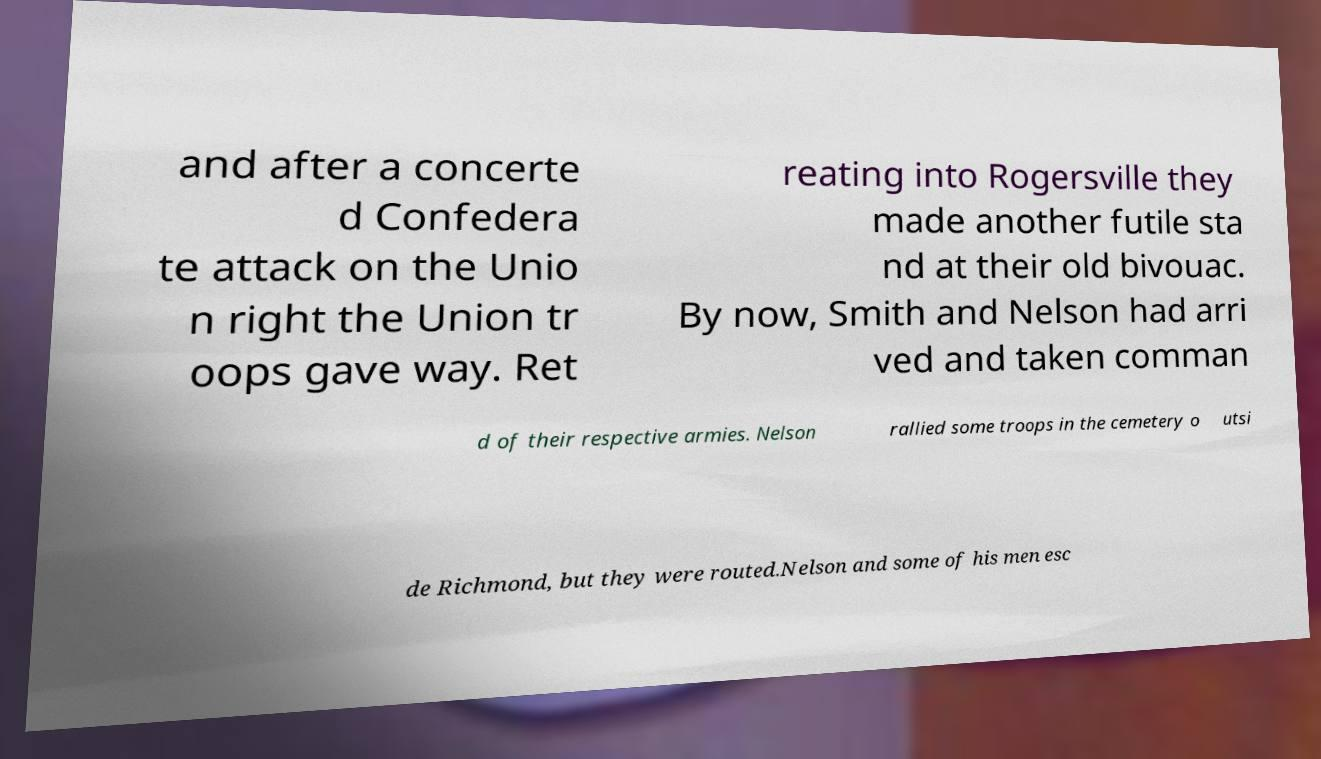I need the written content from this picture converted into text. Can you do that? and after a concerte d Confedera te attack on the Unio n right the Union tr oops gave way. Ret reating into Rogersville they made another futile sta nd at their old bivouac. By now, Smith and Nelson had arri ved and taken comman d of their respective armies. Nelson rallied some troops in the cemetery o utsi de Richmond, but they were routed.Nelson and some of his men esc 